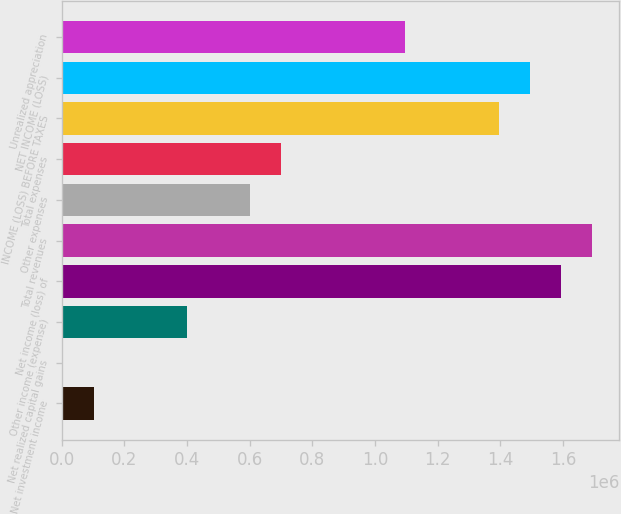Convert chart. <chart><loc_0><loc_0><loc_500><loc_500><bar_chart><fcel>Net investment income<fcel>Net realized capital gains<fcel>Other income (expense)<fcel>Net income (loss) of<fcel>Total revenues<fcel>Other expenses<fcel>Total expenses<fcel>INCOME (LOSS) BEFORE TAXES<fcel>NET INCOME (LOSS)<fcel>Unrealized appreciation<nl><fcel>102562<fcel>3057<fcel>401078<fcel>1.59514e+06<fcel>1.69465e+06<fcel>600088<fcel>699593<fcel>1.39613e+06<fcel>1.49564e+06<fcel>1.09761e+06<nl></chart> 